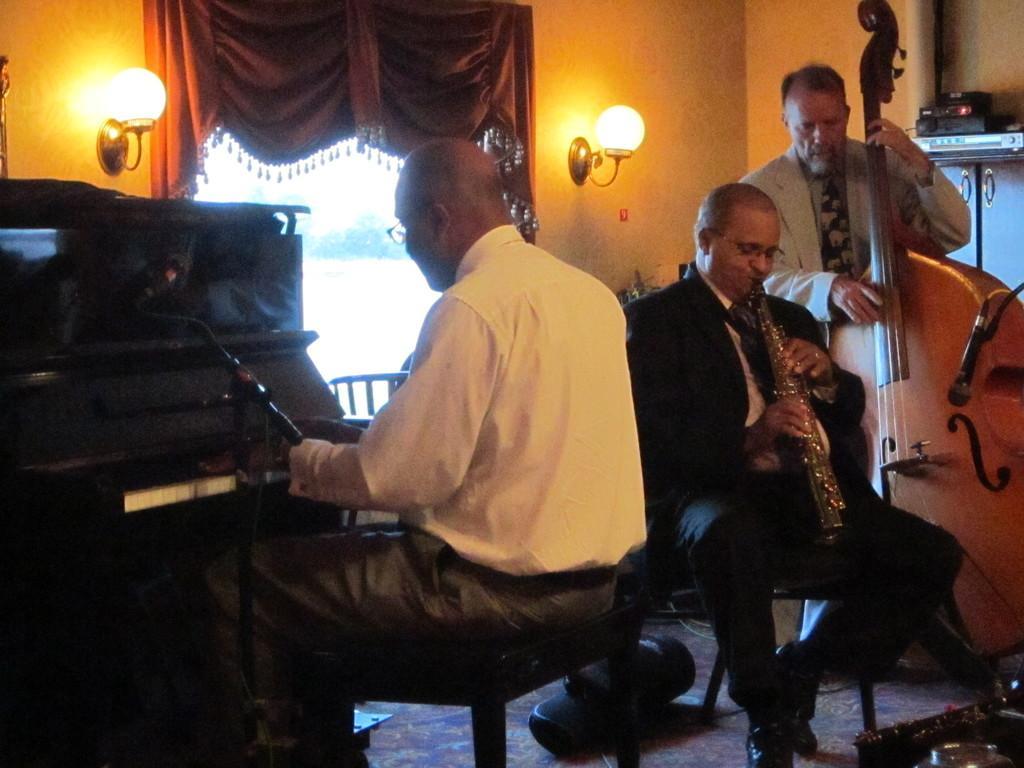Can you describe this image briefly? There are three members in this room. Everyone is playing a different musical instrument. Two of them were wearing spectacles and they are sitting. One man is standing in the right side. In a background, there is a curtain, light and a wall here. 